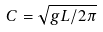<formula> <loc_0><loc_0><loc_500><loc_500>C = \sqrt { g L / 2 \pi }</formula> 